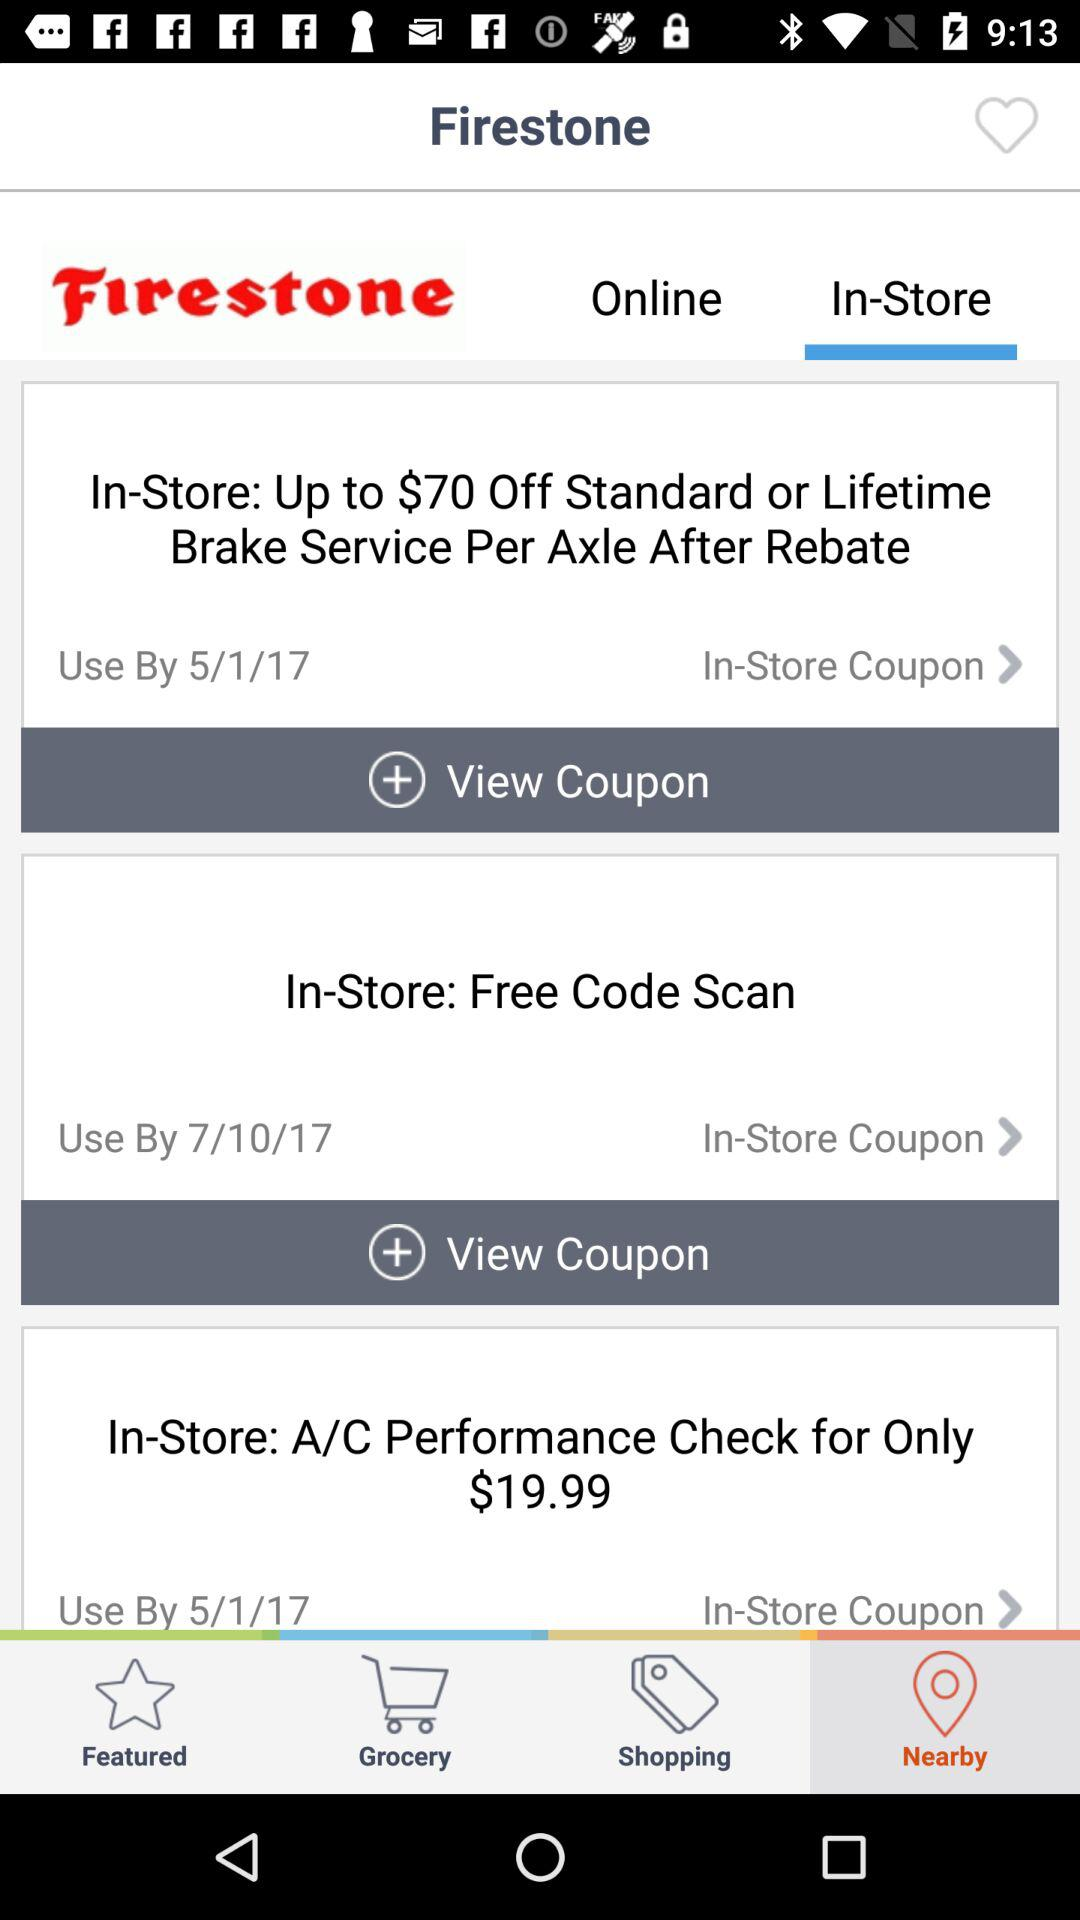What is the name of the application? The name of the application is "Firestone". 